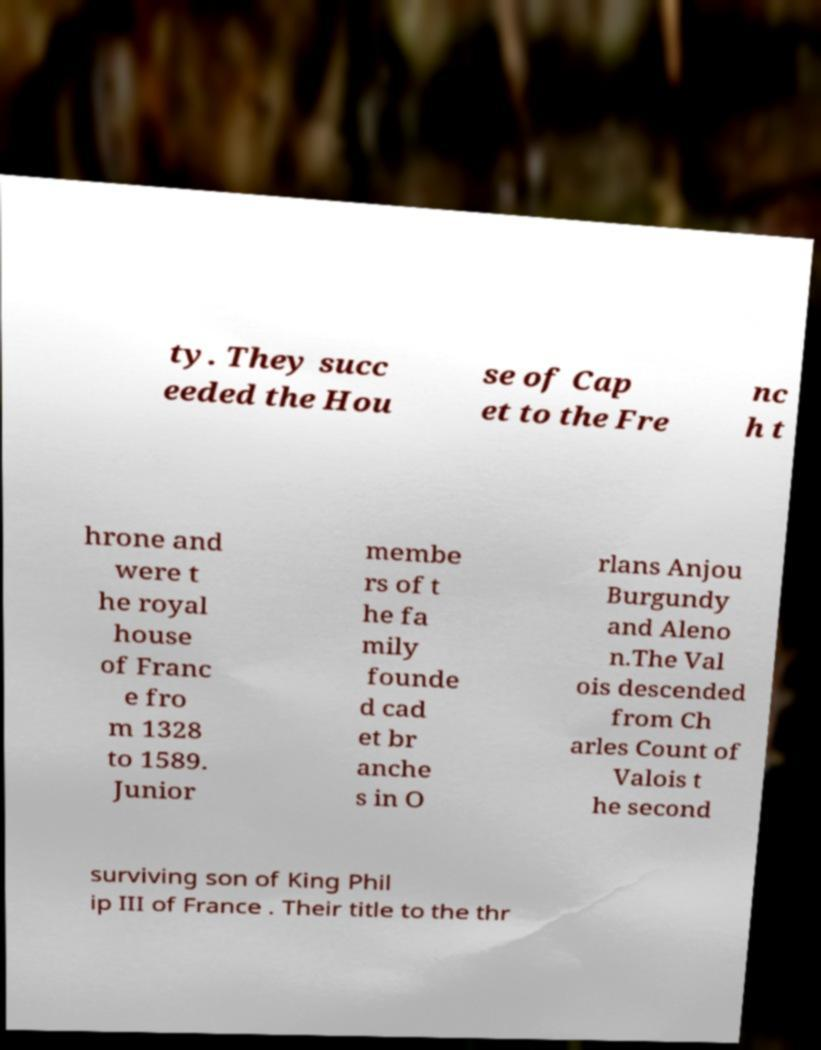I need the written content from this picture converted into text. Can you do that? ty. They succ eeded the Hou se of Cap et to the Fre nc h t hrone and were t he royal house of Franc e fro m 1328 to 1589. Junior membe rs of t he fa mily founde d cad et br anche s in O rlans Anjou Burgundy and Aleno n.The Val ois descended from Ch arles Count of Valois t he second surviving son of King Phil ip III of France . Their title to the thr 